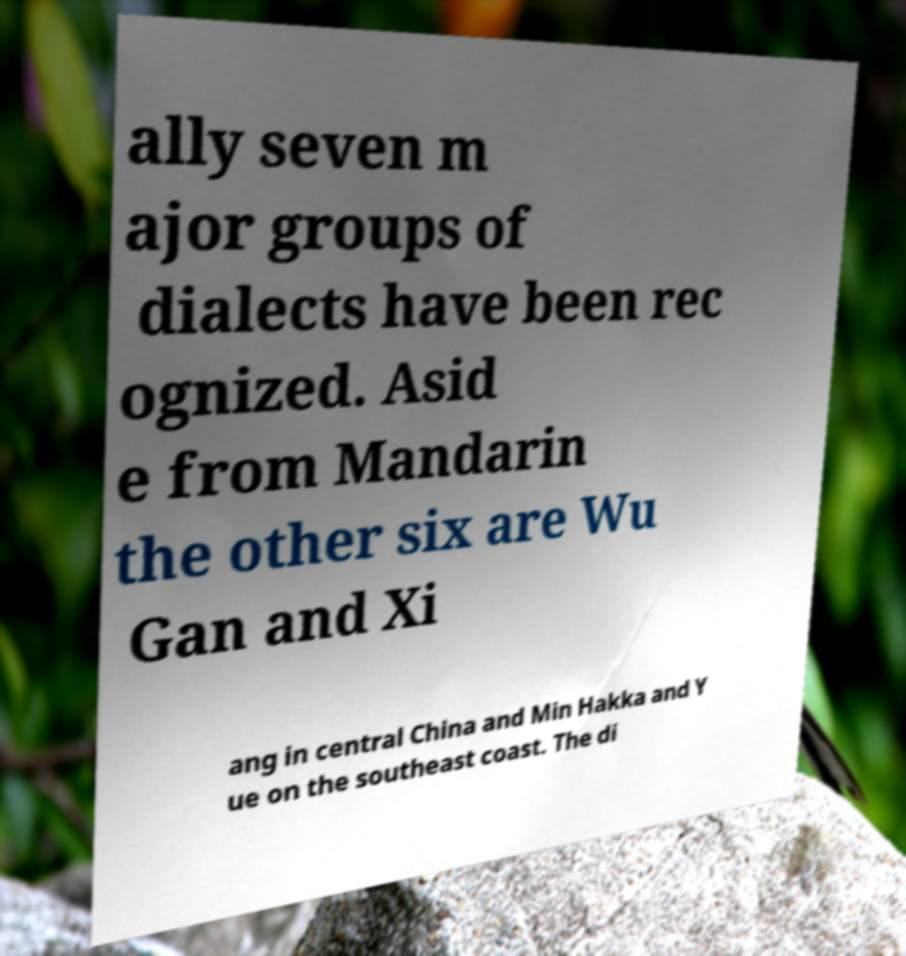What messages or text are displayed in this image? I need them in a readable, typed format. ally seven m ajor groups of dialects have been rec ognized. Asid e from Mandarin the other six are Wu Gan and Xi ang in central China and Min Hakka and Y ue on the southeast coast. The di 